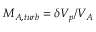Convert formula to latex. <formula><loc_0><loc_0><loc_500><loc_500>M _ { A , t u r b } = \delta V _ { p } / V _ { A }</formula> 